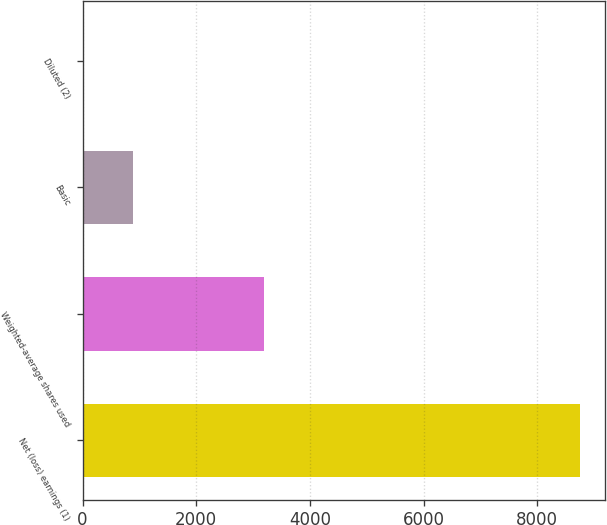<chart> <loc_0><loc_0><loc_500><loc_500><bar_chart><fcel>Net (loss) earnings (1)<fcel>Weighted-average shares used<fcel>Basic<fcel>Diluted (2)<nl><fcel>8761<fcel>3194.73<fcel>879.42<fcel>3.69<nl></chart> 